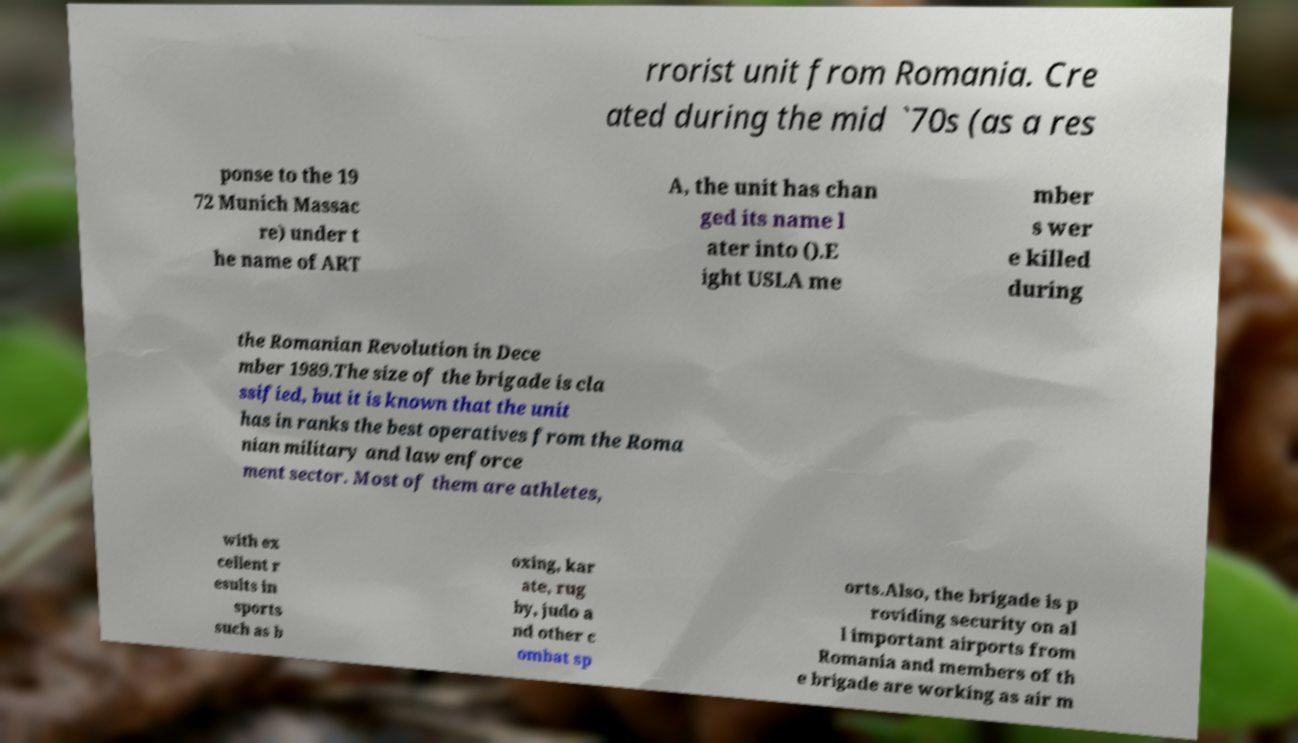Can you read and provide the text displayed in the image?This photo seems to have some interesting text. Can you extract and type it out for me? rrorist unit from Romania. Cre ated during the mid `70s (as a res ponse to the 19 72 Munich Massac re) under t he name of ART A, the unit has chan ged its name l ater into ().E ight USLA me mber s wer e killed during the Romanian Revolution in Dece mber 1989.The size of the brigade is cla ssified, but it is known that the unit has in ranks the best operatives from the Roma nian military and law enforce ment sector. Most of them are athletes, with ex cellent r esults in sports such as b oxing, kar ate, rug by, judo a nd other c ombat sp orts.Also, the brigade is p roviding security on al l important airports from Romania and members of th e brigade are working as air m 